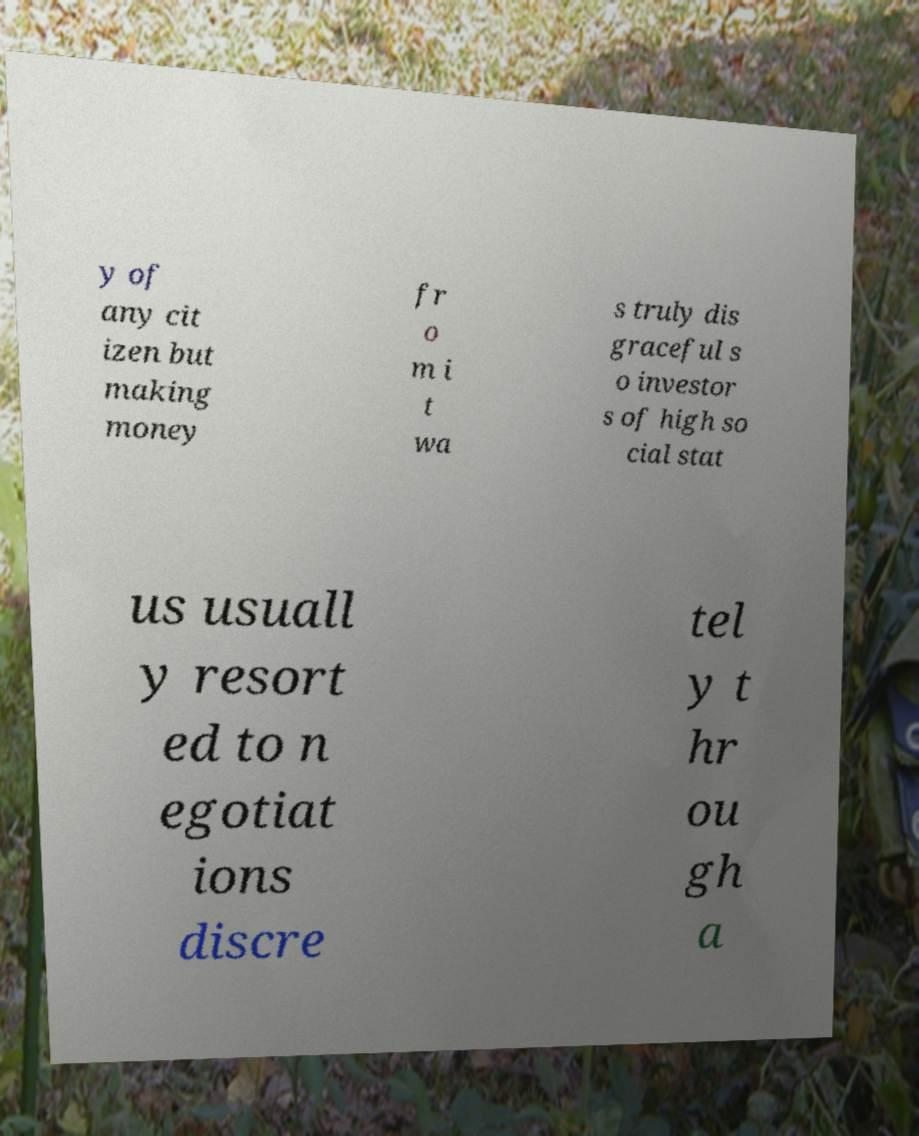Please read and relay the text visible in this image. What does it say? y of any cit izen but making money fr o m i t wa s truly dis graceful s o investor s of high so cial stat us usuall y resort ed to n egotiat ions discre tel y t hr ou gh a 